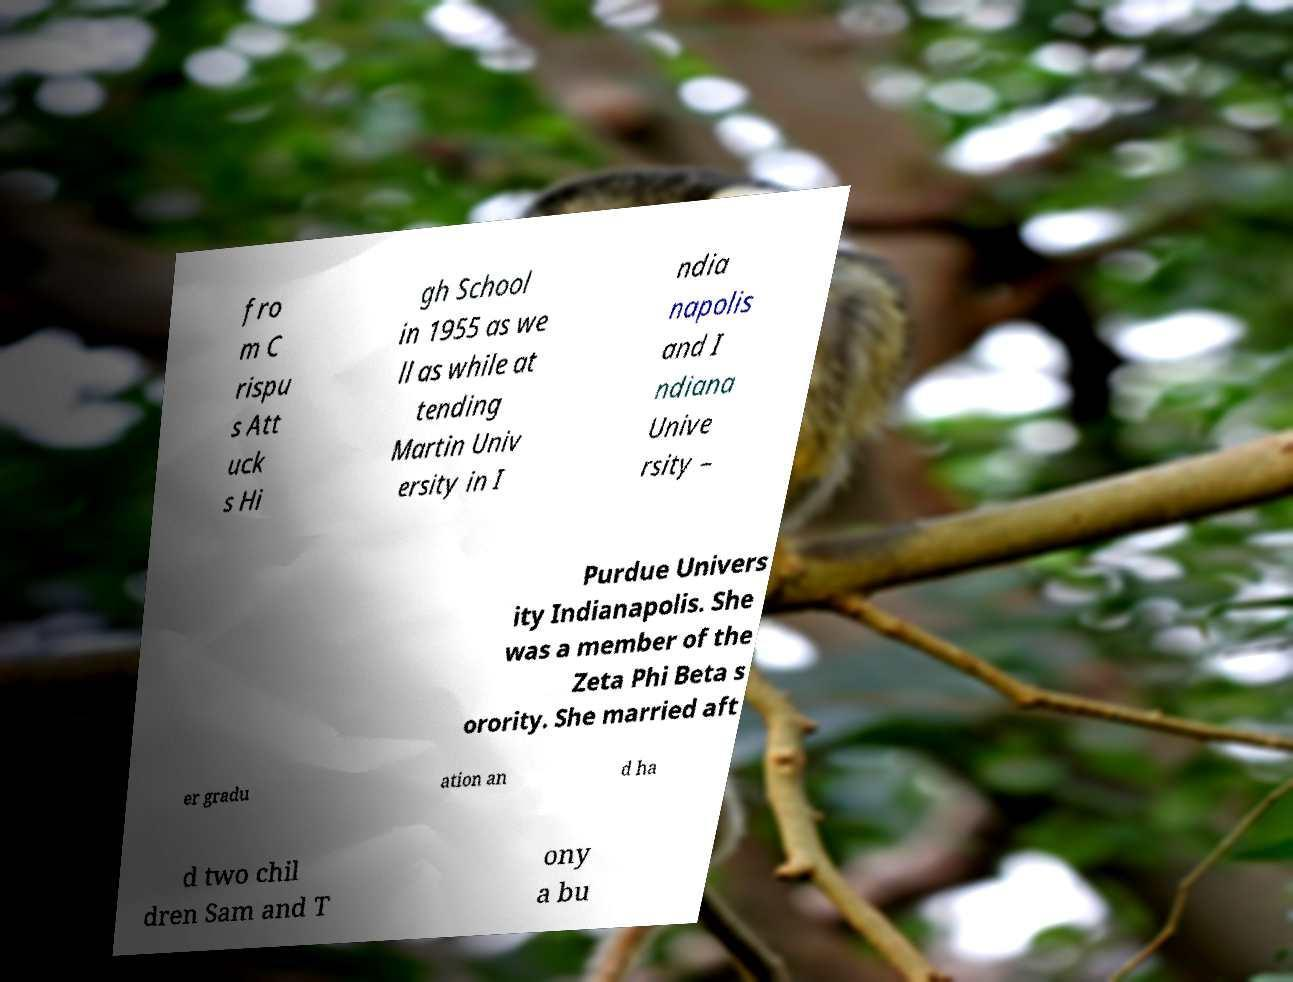Can you accurately transcribe the text from the provided image for me? fro m C rispu s Att uck s Hi gh School in 1955 as we ll as while at tending Martin Univ ersity in I ndia napolis and I ndiana Unive rsity – Purdue Univers ity Indianapolis. She was a member of the Zeta Phi Beta s orority. She married aft er gradu ation an d ha d two chil dren Sam and T ony a bu 